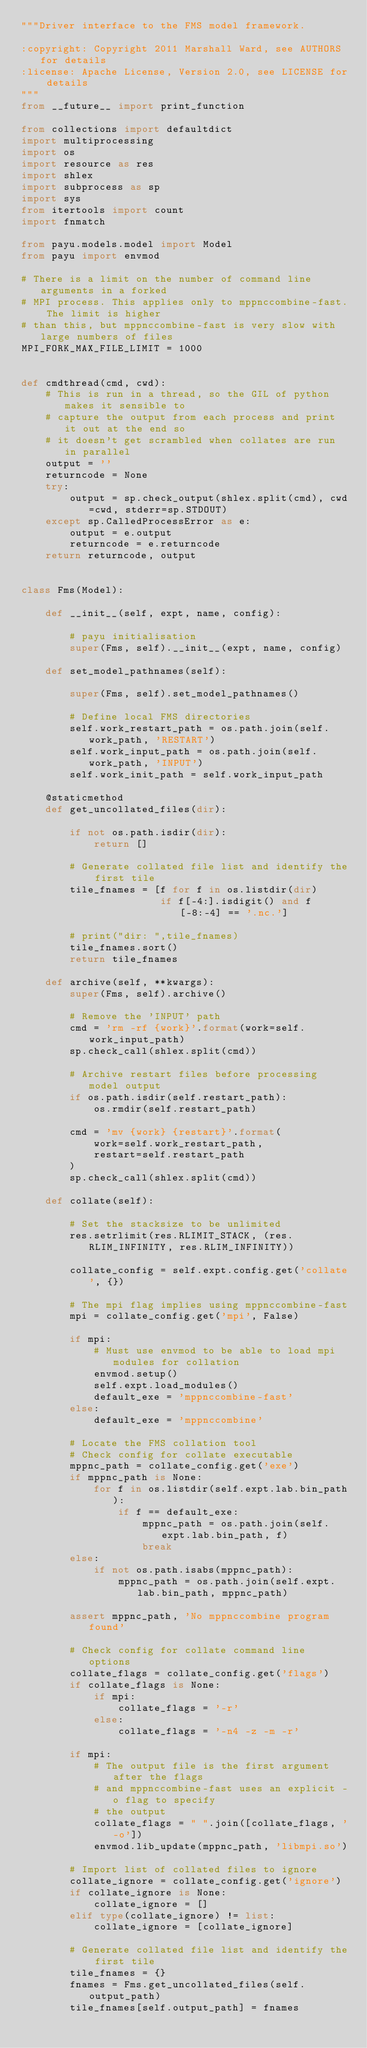<code> <loc_0><loc_0><loc_500><loc_500><_Python_>"""Driver interface to the FMS model framework.

:copyright: Copyright 2011 Marshall Ward, see AUTHORS for details
:license: Apache License, Version 2.0, see LICENSE for details
"""
from __future__ import print_function

from collections import defaultdict
import multiprocessing
import os
import resource as res
import shlex
import subprocess as sp
import sys
from itertools import count
import fnmatch

from payu.models.model import Model
from payu import envmod

# There is a limit on the number of command line arguments in a forked
# MPI process. This applies only to mppnccombine-fast. The limit is higher
# than this, but mppnccombine-fast is very slow with large numbers of files
MPI_FORK_MAX_FILE_LIMIT = 1000


def cmdthread(cmd, cwd):
    # This is run in a thread, so the GIL of python makes it sensible to
    # capture the output from each process and print it out at the end so
    # it doesn't get scrambled when collates are run in parallel
    output = ''
    returncode = None
    try:
        output = sp.check_output(shlex.split(cmd), cwd=cwd, stderr=sp.STDOUT)
    except sp.CalledProcessError as e:
        output = e.output
        returncode = e.returncode
    return returncode, output


class Fms(Model):

    def __init__(self, expt, name, config):

        # payu initialisation
        super(Fms, self).__init__(expt, name, config)

    def set_model_pathnames(self):

        super(Fms, self).set_model_pathnames()

        # Define local FMS directories
        self.work_restart_path = os.path.join(self.work_path, 'RESTART')
        self.work_input_path = os.path.join(self.work_path, 'INPUT')
        self.work_init_path = self.work_input_path

    @staticmethod
    def get_uncollated_files(dir):

        if not os.path.isdir(dir):
            return []

        # Generate collated file list and identify the first tile
        tile_fnames = [f for f in os.listdir(dir)
                       if f[-4:].isdigit() and f[-8:-4] == '.nc.']

        # print("dir: ",tile_fnames)
        tile_fnames.sort()
        return tile_fnames

    def archive(self, **kwargs):
        super(Fms, self).archive()

        # Remove the 'INPUT' path
        cmd = 'rm -rf {work}'.format(work=self.work_input_path)
        sp.check_call(shlex.split(cmd))

        # Archive restart files before processing model output
        if os.path.isdir(self.restart_path):
            os.rmdir(self.restart_path)

        cmd = 'mv {work} {restart}'.format(
            work=self.work_restart_path,
            restart=self.restart_path
        )
        sp.check_call(shlex.split(cmd))

    def collate(self):

        # Set the stacksize to be unlimited
        res.setrlimit(res.RLIMIT_STACK, (res.RLIM_INFINITY, res.RLIM_INFINITY))

        collate_config = self.expt.config.get('collate', {})

        # The mpi flag implies using mppnccombine-fast
        mpi = collate_config.get('mpi', False)

        if mpi:
            # Must use envmod to be able to load mpi modules for collation
            envmod.setup()
            self.expt.load_modules()
            default_exe = 'mppnccombine-fast'
        else:
            default_exe = 'mppnccombine'

        # Locate the FMS collation tool
        # Check config for collate executable
        mppnc_path = collate_config.get('exe')
        if mppnc_path is None:
            for f in os.listdir(self.expt.lab.bin_path):
                if f == default_exe:
                    mppnc_path = os.path.join(self.expt.lab.bin_path, f)
                    break
        else:
            if not os.path.isabs(mppnc_path):
                mppnc_path = os.path.join(self.expt.lab.bin_path, mppnc_path)

        assert mppnc_path, 'No mppnccombine program found'

        # Check config for collate command line options
        collate_flags = collate_config.get('flags')
        if collate_flags is None:
            if mpi:
                collate_flags = '-r'
            else:
                collate_flags = '-n4 -z -m -r'

        if mpi:
            # The output file is the first argument after the flags
            # and mppnccombine-fast uses an explicit -o flag to specify
            # the output
            collate_flags = " ".join([collate_flags, '-o'])
            envmod.lib_update(mppnc_path, 'libmpi.so')

        # Import list of collated files to ignore
        collate_ignore = collate_config.get('ignore')
        if collate_ignore is None:
            collate_ignore = []
        elif type(collate_ignore) != list:
            collate_ignore = [collate_ignore]

        # Generate collated file list and identify the first tile
        tile_fnames = {}
        fnames = Fms.get_uncollated_files(self.output_path)
        tile_fnames[self.output_path] = fnames
</code> 